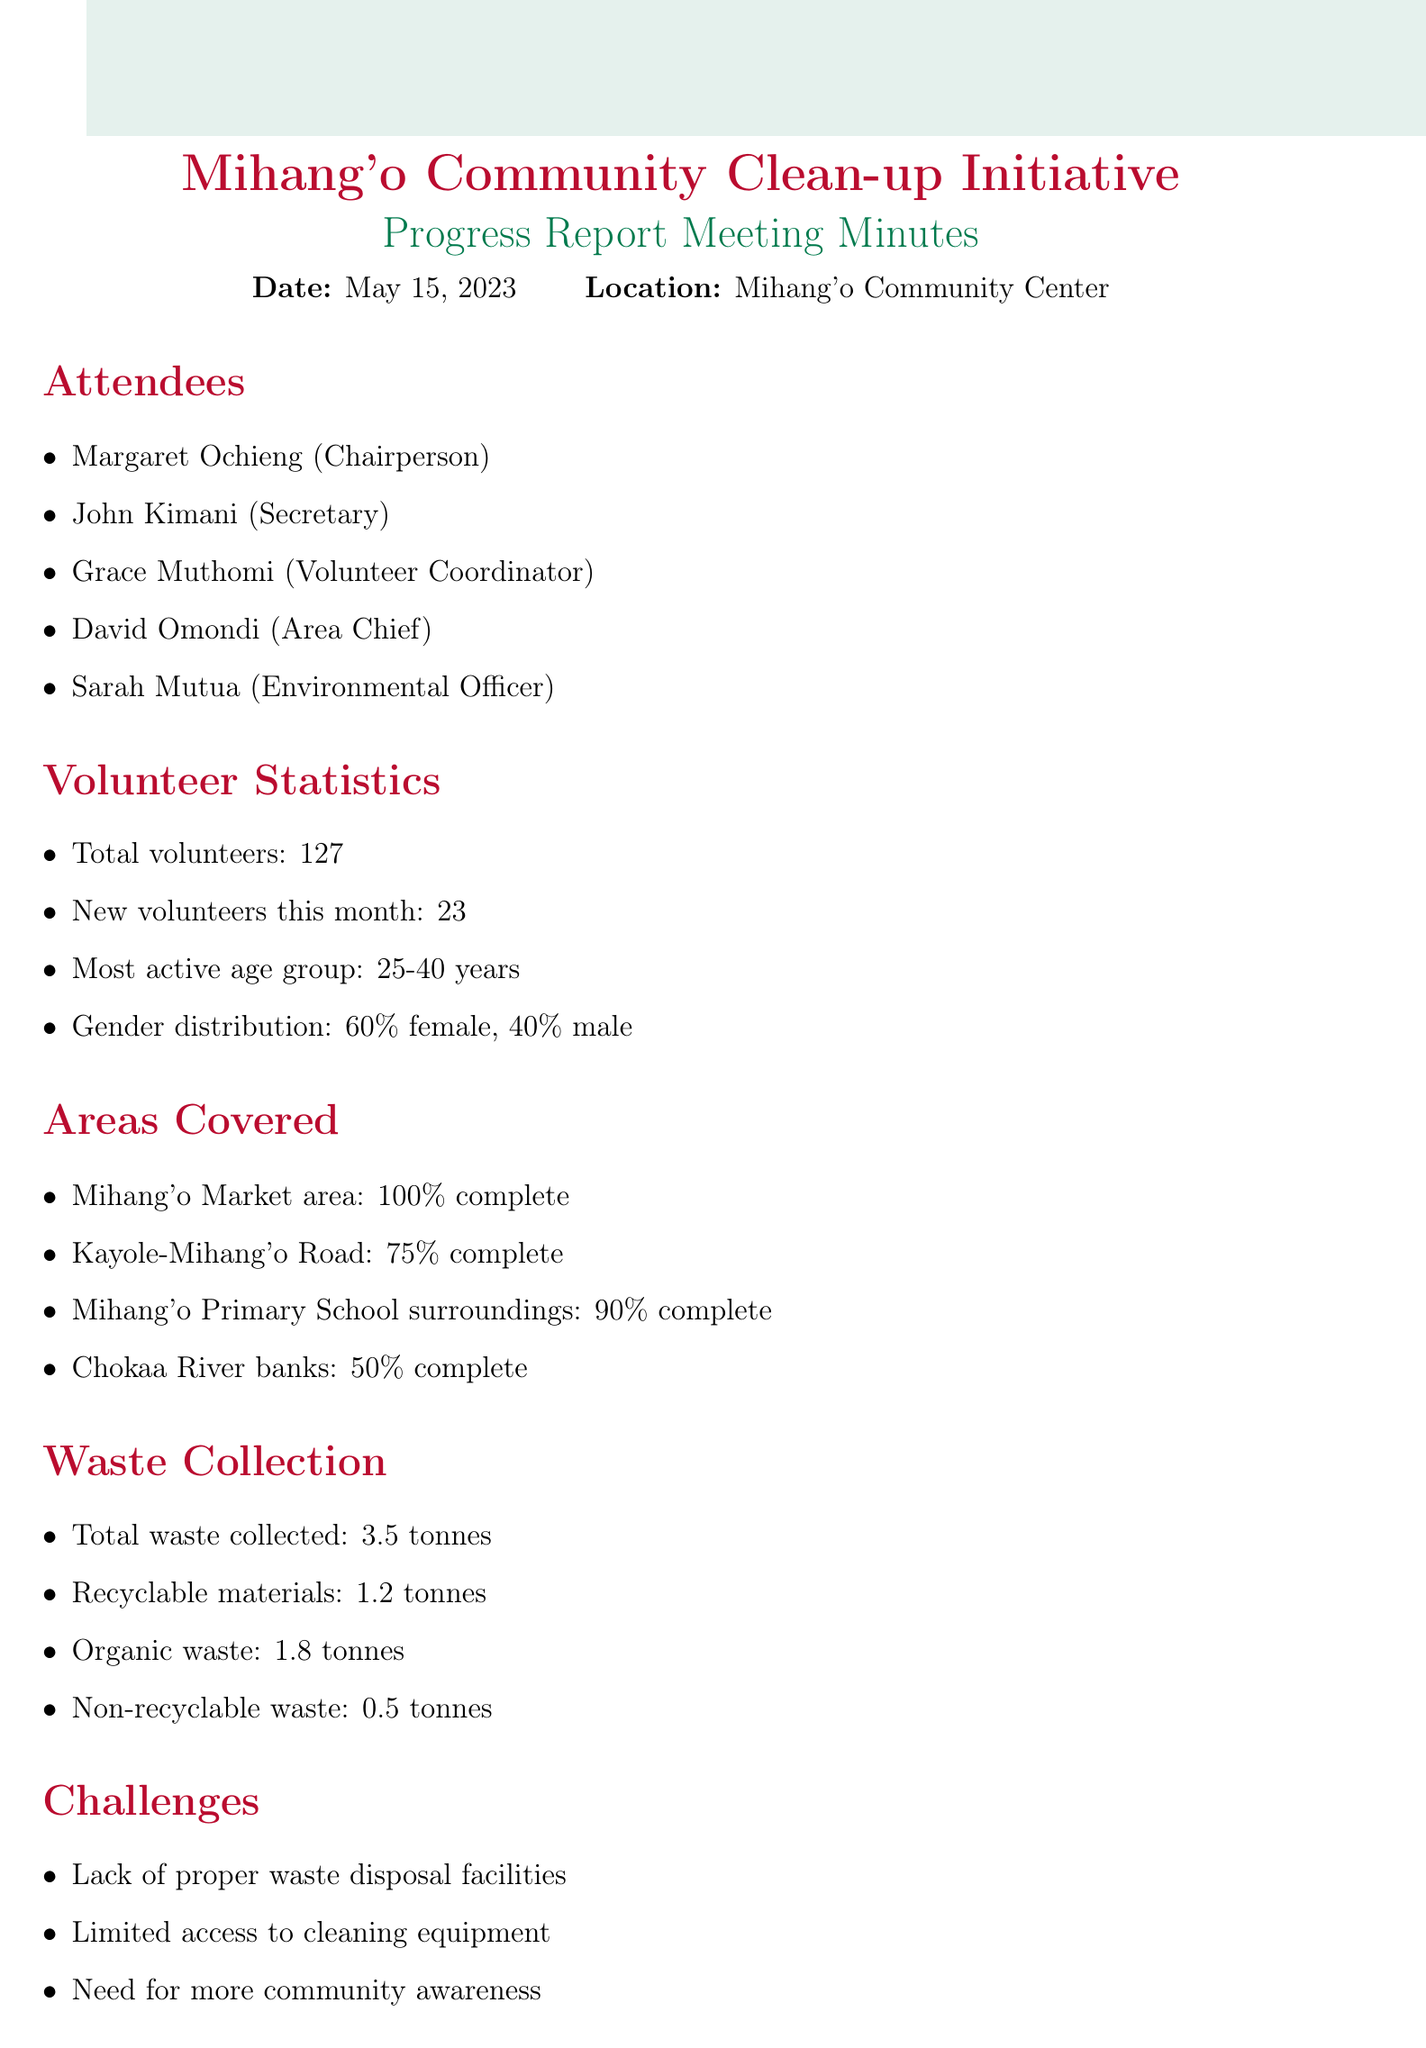What is the date of the meeting? The date of the meeting is specified in the document.
Answer: May 15, 2023 How many total volunteers participated? The document states the total number of volunteers.
Answer: 127 Which area is 100% complete? The document lists the areas and their completion percentages.
Answer: Mihang'o Market area What percentage of waste collected is recyclable? The document indicates the total waste and the category of recyclable materials.
Answer: 1.2 tonnes What is the most active age group among volunteers? The document mentions the most active age group in the statistics section.
Answer: 25-40 years What is one of the challenges faced by the initiative? The document outlines several challenges faced during the clean-up initiative.
Answer: Lack of proper waste disposal facilities What is one of the next steps mentioned? The document lists what actions will be taken next.
Answer: Organize community sensitization workshop What is the gender distribution of the volunteers? The document provides information on the gender distribution among volunteers.
Answer: 60% female, 40% male What was the total waste collected during the initiative? The document provides precise numbers about the waste collected.
Answer: 3.5 tonnes 